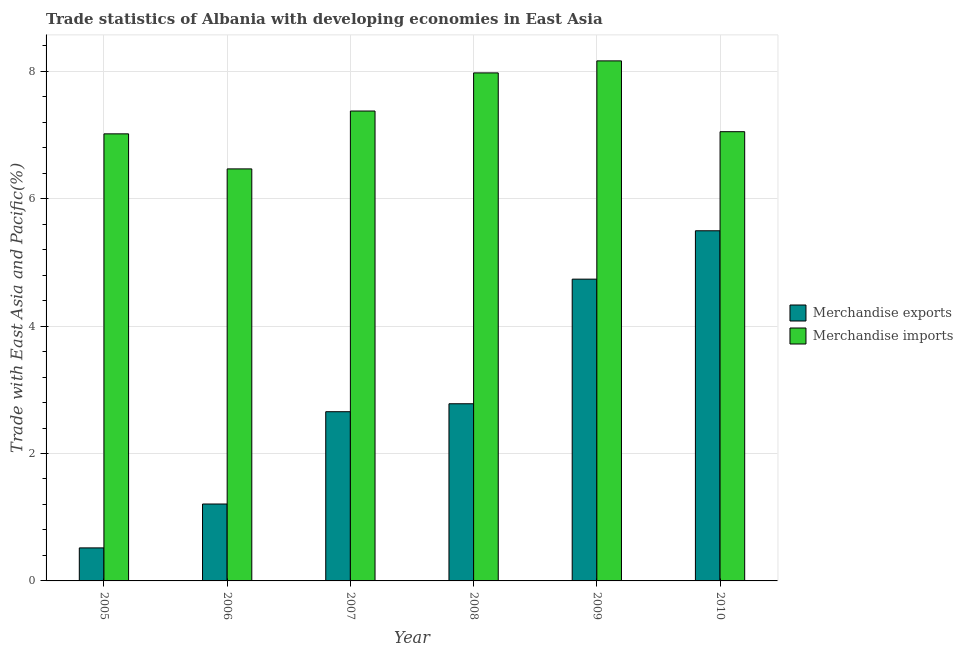How many different coloured bars are there?
Provide a short and direct response. 2. Are the number of bars per tick equal to the number of legend labels?
Provide a short and direct response. Yes. How many bars are there on the 5th tick from the right?
Give a very brief answer. 2. What is the merchandise exports in 2009?
Your answer should be very brief. 4.74. Across all years, what is the maximum merchandise imports?
Provide a short and direct response. 8.16. Across all years, what is the minimum merchandise imports?
Make the answer very short. 6.47. In which year was the merchandise imports maximum?
Keep it short and to the point. 2009. In which year was the merchandise imports minimum?
Your answer should be very brief. 2006. What is the total merchandise imports in the graph?
Give a very brief answer. 44.05. What is the difference between the merchandise imports in 2009 and that in 2010?
Give a very brief answer. 1.11. What is the difference between the merchandise imports in 2008 and the merchandise exports in 2009?
Your answer should be compact. -0.19. What is the average merchandise imports per year?
Make the answer very short. 7.34. In how many years, is the merchandise imports greater than 6.4 %?
Make the answer very short. 6. What is the ratio of the merchandise imports in 2005 to that in 2006?
Ensure brevity in your answer.  1.09. Is the merchandise imports in 2005 less than that in 2007?
Your response must be concise. Yes. Is the difference between the merchandise exports in 2006 and 2007 greater than the difference between the merchandise imports in 2006 and 2007?
Provide a short and direct response. No. What is the difference between the highest and the second highest merchandise exports?
Provide a succinct answer. 0.76. What is the difference between the highest and the lowest merchandise imports?
Provide a succinct answer. 1.7. Is the sum of the merchandise exports in 2008 and 2010 greater than the maximum merchandise imports across all years?
Your answer should be compact. Yes. What does the 1st bar from the left in 2009 represents?
Give a very brief answer. Merchandise exports. How many bars are there?
Ensure brevity in your answer.  12. How many years are there in the graph?
Make the answer very short. 6. What is the difference between two consecutive major ticks on the Y-axis?
Offer a terse response. 2. How many legend labels are there?
Provide a succinct answer. 2. How are the legend labels stacked?
Give a very brief answer. Vertical. What is the title of the graph?
Your response must be concise. Trade statistics of Albania with developing economies in East Asia. What is the label or title of the Y-axis?
Provide a succinct answer. Trade with East Asia and Pacific(%). What is the Trade with East Asia and Pacific(%) of Merchandise exports in 2005?
Provide a succinct answer. 0.52. What is the Trade with East Asia and Pacific(%) of Merchandise imports in 2005?
Offer a very short reply. 7.02. What is the Trade with East Asia and Pacific(%) of Merchandise exports in 2006?
Provide a succinct answer. 1.21. What is the Trade with East Asia and Pacific(%) in Merchandise imports in 2006?
Your answer should be compact. 6.47. What is the Trade with East Asia and Pacific(%) in Merchandise exports in 2007?
Your response must be concise. 2.66. What is the Trade with East Asia and Pacific(%) in Merchandise imports in 2007?
Offer a terse response. 7.38. What is the Trade with East Asia and Pacific(%) in Merchandise exports in 2008?
Offer a very short reply. 2.78. What is the Trade with East Asia and Pacific(%) of Merchandise imports in 2008?
Your answer should be compact. 7.97. What is the Trade with East Asia and Pacific(%) in Merchandise exports in 2009?
Offer a very short reply. 4.74. What is the Trade with East Asia and Pacific(%) in Merchandise imports in 2009?
Keep it short and to the point. 8.16. What is the Trade with East Asia and Pacific(%) in Merchandise exports in 2010?
Offer a terse response. 5.5. What is the Trade with East Asia and Pacific(%) in Merchandise imports in 2010?
Keep it short and to the point. 7.05. Across all years, what is the maximum Trade with East Asia and Pacific(%) in Merchandise exports?
Your answer should be compact. 5.5. Across all years, what is the maximum Trade with East Asia and Pacific(%) of Merchandise imports?
Make the answer very short. 8.16. Across all years, what is the minimum Trade with East Asia and Pacific(%) in Merchandise exports?
Your answer should be compact. 0.52. Across all years, what is the minimum Trade with East Asia and Pacific(%) in Merchandise imports?
Keep it short and to the point. 6.47. What is the total Trade with East Asia and Pacific(%) of Merchandise exports in the graph?
Your response must be concise. 17.39. What is the total Trade with East Asia and Pacific(%) in Merchandise imports in the graph?
Your response must be concise. 44.05. What is the difference between the Trade with East Asia and Pacific(%) in Merchandise exports in 2005 and that in 2006?
Provide a short and direct response. -0.69. What is the difference between the Trade with East Asia and Pacific(%) in Merchandise imports in 2005 and that in 2006?
Keep it short and to the point. 0.55. What is the difference between the Trade with East Asia and Pacific(%) of Merchandise exports in 2005 and that in 2007?
Your answer should be very brief. -2.14. What is the difference between the Trade with East Asia and Pacific(%) of Merchandise imports in 2005 and that in 2007?
Keep it short and to the point. -0.36. What is the difference between the Trade with East Asia and Pacific(%) of Merchandise exports in 2005 and that in 2008?
Keep it short and to the point. -2.26. What is the difference between the Trade with East Asia and Pacific(%) of Merchandise imports in 2005 and that in 2008?
Provide a short and direct response. -0.96. What is the difference between the Trade with East Asia and Pacific(%) in Merchandise exports in 2005 and that in 2009?
Keep it short and to the point. -4.22. What is the difference between the Trade with East Asia and Pacific(%) in Merchandise imports in 2005 and that in 2009?
Make the answer very short. -1.15. What is the difference between the Trade with East Asia and Pacific(%) of Merchandise exports in 2005 and that in 2010?
Your answer should be very brief. -4.98. What is the difference between the Trade with East Asia and Pacific(%) in Merchandise imports in 2005 and that in 2010?
Your answer should be very brief. -0.03. What is the difference between the Trade with East Asia and Pacific(%) in Merchandise exports in 2006 and that in 2007?
Give a very brief answer. -1.45. What is the difference between the Trade with East Asia and Pacific(%) of Merchandise imports in 2006 and that in 2007?
Your answer should be compact. -0.91. What is the difference between the Trade with East Asia and Pacific(%) of Merchandise exports in 2006 and that in 2008?
Offer a very short reply. -1.57. What is the difference between the Trade with East Asia and Pacific(%) of Merchandise imports in 2006 and that in 2008?
Make the answer very short. -1.51. What is the difference between the Trade with East Asia and Pacific(%) of Merchandise exports in 2006 and that in 2009?
Your answer should be very brief. -3.53. What is the difference between the Trade with East Asia and Pacific(%) in Merchandise imports in 2006 and that in 2009?
Your response must be concise. -1.7. What is the difference between the Trade with East Asia and Pacific(%) in Merchandise exports in 2006 and that in 2010?
Offer a terse response. -4.29. What is the difference between the Trade with East Asia and Pacific(%) of Merchandise imports in 2006 and that in 2010?
Make the answer very short. -0.58. What is the difference between the Trade with East Asia and Pacific(%) of Merchandise exports in 2007 and that in 2008?
Keep it short and to the point. -0.12. What is the difference between the Trade with East Asia and Pacific(%) of Merchandise imports in 2007 and that in 2008?
Provide a succinct answer. -0.6. What is the difference between the Trade with East Asia and Pacific(%) in Merchandise exports in 2007 and that in 2009?
Offer a very short reply. -2.08. What is the difference between the Trade with East Asia and Pacific(%) of Merchandise imports in 2007 and that in 2009?
Your answer should be compact. -0.79. What is the difference between the Trade with East Asia and Pacific(%) in Merchandise exports in 2007 and that in 2010?
Your answer should be compact. -2.84. What is the difference between the Trade with East Asia and Pacific(%) of Merchandise imports in 2007 and that in 2010?
Give a very brief answer. 0.32. What is the difference between the Trade with East Asia and Pacific(%) in Merchandise exports in 2008 and that in 2009?
Your answer should be compact. -1.96. What is the difference between the Trade with East Asia and Pacific(%) in Merchandise imports in 2008 and that in 2009?
Ensure brevity in your answer.  -0.19. What is the difference between the Trade with East Asia and Pacific(%) of Merchandise exports in 2008 and that in 2010?
Your answer should be very brief. -2.72. What is the difference between the Trade with East Asia and Pacific(%) in Merchandise imports in 2008 and that in 2010?
Your response must be concise. 0.92. What is the difference between the Trade with East Asia and Pacific(%) in Merchandise exports in 2009 and that in 2010?
Provide a succinct answer. -0.76. What is the difference between the Trade with East Asia and Pacific(%) in Merchandise imports in 2009 and that in 2010?
Offer a terse response. 1.11. What is the difference between the Trade with East Asia and Pacific(%) of Merchandise exports in 2005 and the Trade with East Asia and Pacific(%) of Merchandise imports in 2006?
Ensure brevity in your answer.  -5.95. What is the difference between the Trade with East Asia and Pacific(%) of Merchandise exports in 2005 and the Trade with East Asia and Pacific(%) of Merchandise imports in 2007?
Give a very brief answer. -6.86. What is the difference between the Trade with East Asia and Pacific(%) of Merchandise exports in 2005 and the Trade with East Asia and Pacific(%) of Merchandise imports in 2008?
Offer a terse response. -7.46. What is the difference between the Trade with East Asia and Pacific(%) of Merchandise exports in 2005 and the Trade with East Asia and Pacific(%) of Merchandise imports in 2009?
Your answer should be compact. -7.64. What is the difference between the Trade with East Asia and Pacific(%) of Merchandise exports in 2005 and the Trade with East Asia and Pacific(%) of Merchandise imports in 2010?
Provide a succinct answer. -6.53. What is the difference between the Trade with East Asia and Pacific(%) in Merchandise exports in 2006 and the Trade with East Asia and Pacific(%) in Merchandise imports in 2007?
Make the answer very short. -6.17. What is the difference between the Trade with East Asia and Pacific(%) in Merchandise exports in 2006 and the Trade with East Asia and Pacific(%) in Merchandise imports in 2008?
Your response must be concise. -6.77. What is the difference between the Trade with East Asia and Pacific(%) of Merchandise exports in 2006 and the Trade with East Asia and Pacific(%) of Merchandise imports in 2009?
Your answer should be very brief. -6.96. What is the difference between the Trade with East Asia and Pacific(%) of Merchandise exports in 2006 and the Trade with East Asia and Pacific(%) of Merchandise imports in 2010?
Provide a short and direct response. -5.84. What is the difference between the Trade with East Asia and Pacific(%) in Merchandise exports in 2007 and the Trade with East Asia and Pacific(%) in Merchandise imports in 2008?
Your response must be concise. -5.32. What is the difference between the Trade with East Asia and Pacific(%) of Merchandise exports in 2007 and the Trade with East Asia and Pacific(%) of Merchandise imports in 2009?
Your response must be concise. -5.51. What is the difference between the Trade with East Asia and Pacific(%) of Merchandise exports in 2007 and the Trade with East Asia and Pacific(%) of Merchandise imports in 2010?
Keep it short and to the point. -4.4. What is the difference between the Trade with East Asia and Pacific(%) in Merchandise exports in 2008 and the Trade with East Asia and Pacific(%) in Merchandise imports in 2009?
Your response must be concise. -5.38. What is the difference between the Trade with East Asia and Pacific(%) of Merchandise exports in 2008 and the Trade with East Asia and Pacific(%) of Merchandise imports in 2010?
Ensure brevity in your answer.  -4.27. What is the difference between the Trade with East Asia and Pacific(%) of Merchandise exports in 2009 and the Trade with East Asia and Pacific(%) of Merchandise imports in 2010?
Ensure brevity in your answer.  -2.31. What is the average Trade with East Asia and Pacific(%) of Merchandise exports per year?
Provide a short and direct response. 2.9. What is the average Trade with East Asia and Pacific(%) of Merchandise imports per year?
Provide a succinct answer. 7.34. In the year 2005, what is the difference between the Trade with East Asia and Pacific(%) in Merchandise exports and Trade with East Asia and Pacific(%) in Merchandise imports?
Give a very brief answer. -6.5. In the year 2006, what is the difference between the Trade with East Asia and Pacific(%) in Merchandise exports and Trade with East Asia and Pacific(%) in Merchandise imports?
Keep it short and to the point. -5.26. In the year 2007, what is the difference between the Trade with East Asia and Pacific(%) of Merchandise exports and Trade with East Asia and Pacific(%) of Merchandise imports?
Your answer should be compact. -4.72. In the year 2008, what is the difference between the Trade with East Asia and Pacific(%) in Merchandise exports and Trade with East Asia and Pacific(%) in Merchandise imports?
Keep it short and to the point. -5.19. In the year 2009, what is the difference between the Trade with East Asia and Pacific(%) in Merchandise exports and Trade with East Asia and Pacific(%) in Merchandise imports?
Keep it short and to the point. -3.43. In the year 2010, what is the difference between the Trade with East Asia and Pacific(%) of Merchandise exports and Trade with East Asia and Pacific(%) of Merchandise imports?
Ensure brevity in your answer.  -1.55. What is the ratio of the Trade with East Asia and Pacific(%) in Merchandise exports in 2005 to that in 2006?
Provide a short and direct response. 0.43. What is the ratio of the Trade with East Asia and Pacific(%) of Merchandise imports in 2005 to that in 2006?
Offer a terse response. 1.08. What is the ratio of the Trade with East Asia and Pacific(%) of Merchandise exports in 2005 to that in 2007?
Your response must be concise. 0.2. What is the ratio of the Trade with East Asia and Pacific(%) in Merchandise imports in 2005 to that in 2007?
Make the answer very short. 0.95. What is the ratio of the Trade with East Asia and Pacific(%) of Merchandise exports in 2005 to that in 2008?
Ensure brevity in your answer.  0.19. What is the ratio of the Trade with East Asia and Pacific(%) of Merchandise exports in 2005 to that in 2009?
Offer a terse response. 0.11. What is the ratio of the Trade with East Asia and Pacific(%) in Merchandise imports in 2005 to that in 2009?
Give a very brief answer. 0.86. What is the ratio of the Trade with East Asia and Pacific(%) in Merchandise exports in 2005 to that in 2010?
Make the answer very short. 0.09. What is the ratio of the Trade with East Asia and Pacific(%) of Merchandise exports in 2006 to that in 2007?
Give a very brief answer. 0.45. What is the ratio of the Trade with East Asia and Pacific(%) in Merchandise imports in 2006 to that in 2007?
Offer a very short reply. 0.88. What is the ratio of the Trade with East Asia and Pacific(%) in Merchandise exports in 2006 to that in 2008?
Your response must be concise. 0.43. What is the ratio of the Trade with East Asia and Pacific(%) of Merchandise imports in 2006 to that in 2008?
Keep it short and to the point. 0.81. What is the ratio of the Trade with East Asia and Pacific(%) in Merchandise exports in 2006 to that in 2009?
Provide a succinct answer. 0.25. What is the ratio of the Trade with East Asia and Pacific(%) of Merchandise imports in 2006 to that in 2009?
Your answer should be very brief. 0.79. What is the ratio of the Trade with East Asia and Pacific(%) in Merchandise exports in 2006 to that in 2010?
Ensure brevity in your answer.  0.22. What is the ratio of the Trade with East Asia and Pacific(%) in Merchandise imports in 2006 to that in 2010?
Keep it short and to the point. 0.92. What is the ratio of the Trade with East Asia and Pacific(%) in Merchandise exports in 2007 to that in 2008?
Make the answer very short. 0.96. What is the ratio of the Trade with East Asia and Pacific(%) in Merchandise imports in 2007 to that in 2008?
Your response must be concise. 0.93. What is the ratio of the Trade with East Asia and Pacific(%) of Merchandise exports in 2007 to that in 2009?
Offer a terse response. 0.56. What is the ratio of the Trade with East Asia and Pacific(%) in Merchandise imports in 2007 to that in 2009?
Make the answer very short. 0.9. What is the ratio of the Trade with East Asia and Pacific(%) in Merchandise exports in 2007 to that in 2010?
Make the answer very short. 0.48. What is the ratio of the Trade with East Asia and Pacific(%) in Merchandise imports in 2007 to that in 2010?
Your answer should be very brief. 1.05. What is the ratio of the Trade with East Asia and Pacific(%) of Merchandise exports in 2008 to that in 2009?
Make the answer very short. 0.59. What is the ratio of the Trade with East Asia and Pacific(%) of Merchandise imports in 2008 to that in 2009?
Make the answer very short. 0.98. What is the ratio of the Trade with East Asia and Pacific(%) of Merchandise exports in 2008 to that in 2010?
Keep it short and to the point. 0.51. What is the ratio of the Trade with East Asia and Pacific(%) of Merchandise imports in 2008 to that in 2010?
Your answer should be very brief. 1.13. What is the ratio of the Trade with East Asia and Pacific(%) of Merchandise exports in 2009 to that in 2010?
Keep it short and to the point. 0.86. What is the ratio of the Trade with East Asia and Pacific(%) in Merchandise imports in 2009 to that in 2010?
Keep it short and to the point. 1.16. What is the difference between the highest and the second highest Trade with East Asia and Pacific(%) of Merchandise exports?
Ensure brevity in your answer.  0.76. What is the difference between the highest and the second highest Trade with East Asia and Pacific(%) in Merchandise imports?
Your response must be concise. 0.19. What is the difference between the highest and the lowest Trade with East Asia and Pacific(%) in Merchandise exports?
Offer a terse response. 4.98. What is the difference between the highest and the lowest Trade with East Asia and Pacific(%) in Merchandise imports?
Your response must be concise. 1.7. 